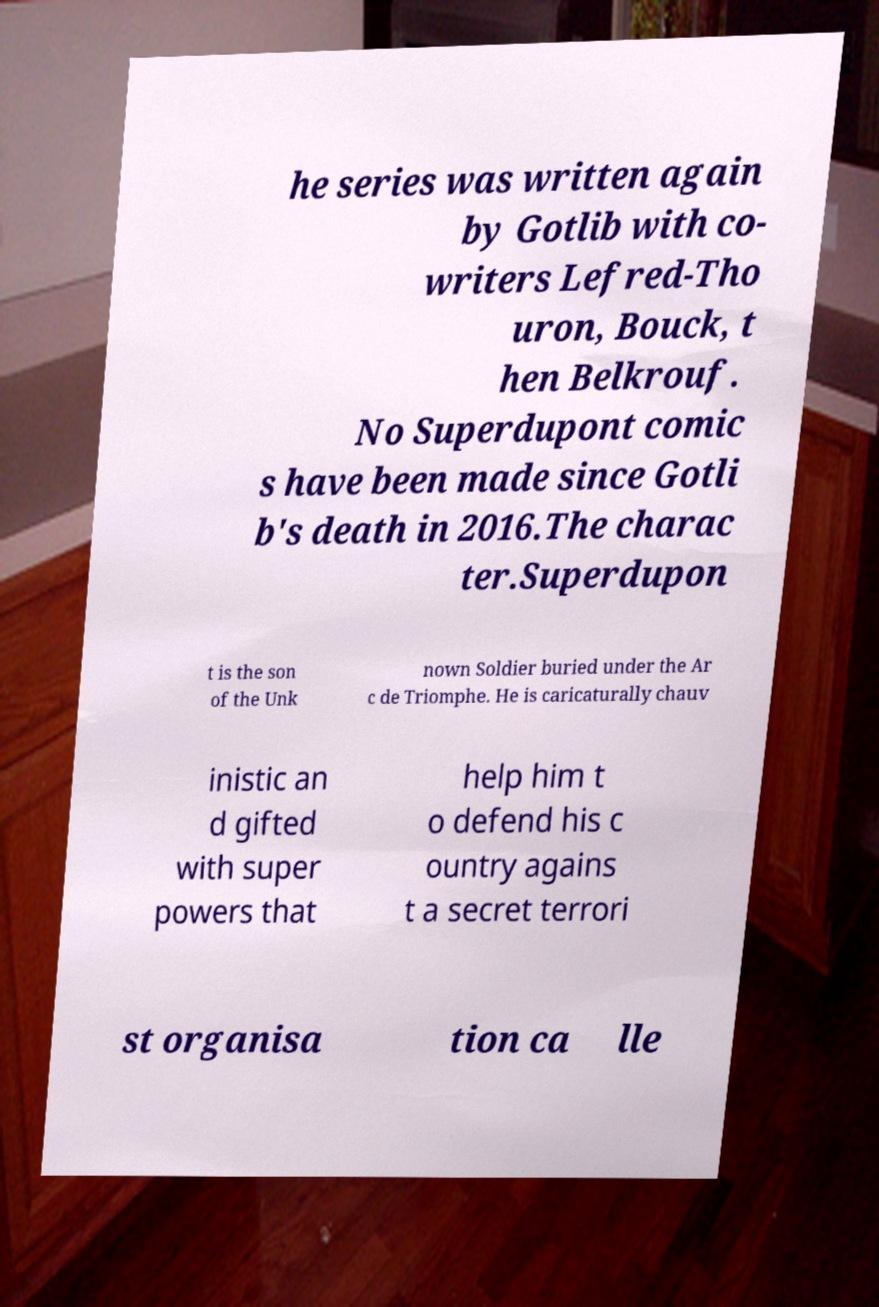Could you extract and type out the text from this image? he series was written again by Gotlib with co- writers Lefred-Tho uron, Bouck, t hen Belkrouf. No Superdupont comic s have been made since Gotli b's death in 2016.The charac ter.Superdupon t is the son of the Unk nown Soldier buried under the Ar c de Triomphe. He is caricaturally chauv inistic an d gifted with super powers that help him t o defend his c ountry agains t a secret terrori st organisa tion ca lle 